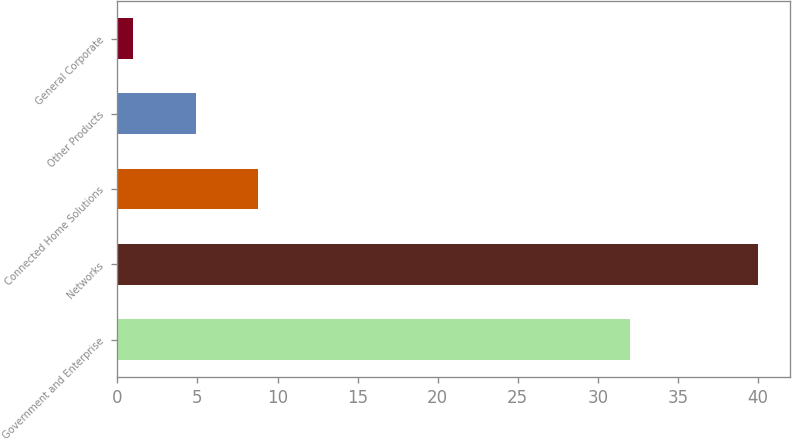Convert chart. <chart><loc_0><loc_0><loc_500><loc_500><bar_chart><fcel>Government and Enterprise<fcel>Networks<fcel>Connected Home Solutions<fcel>Other Products<fcel>General Corporate<nl><fcel>32<fcel>40<fcel>8.8<fcel>4.9<fcel>1<nl></chart> 